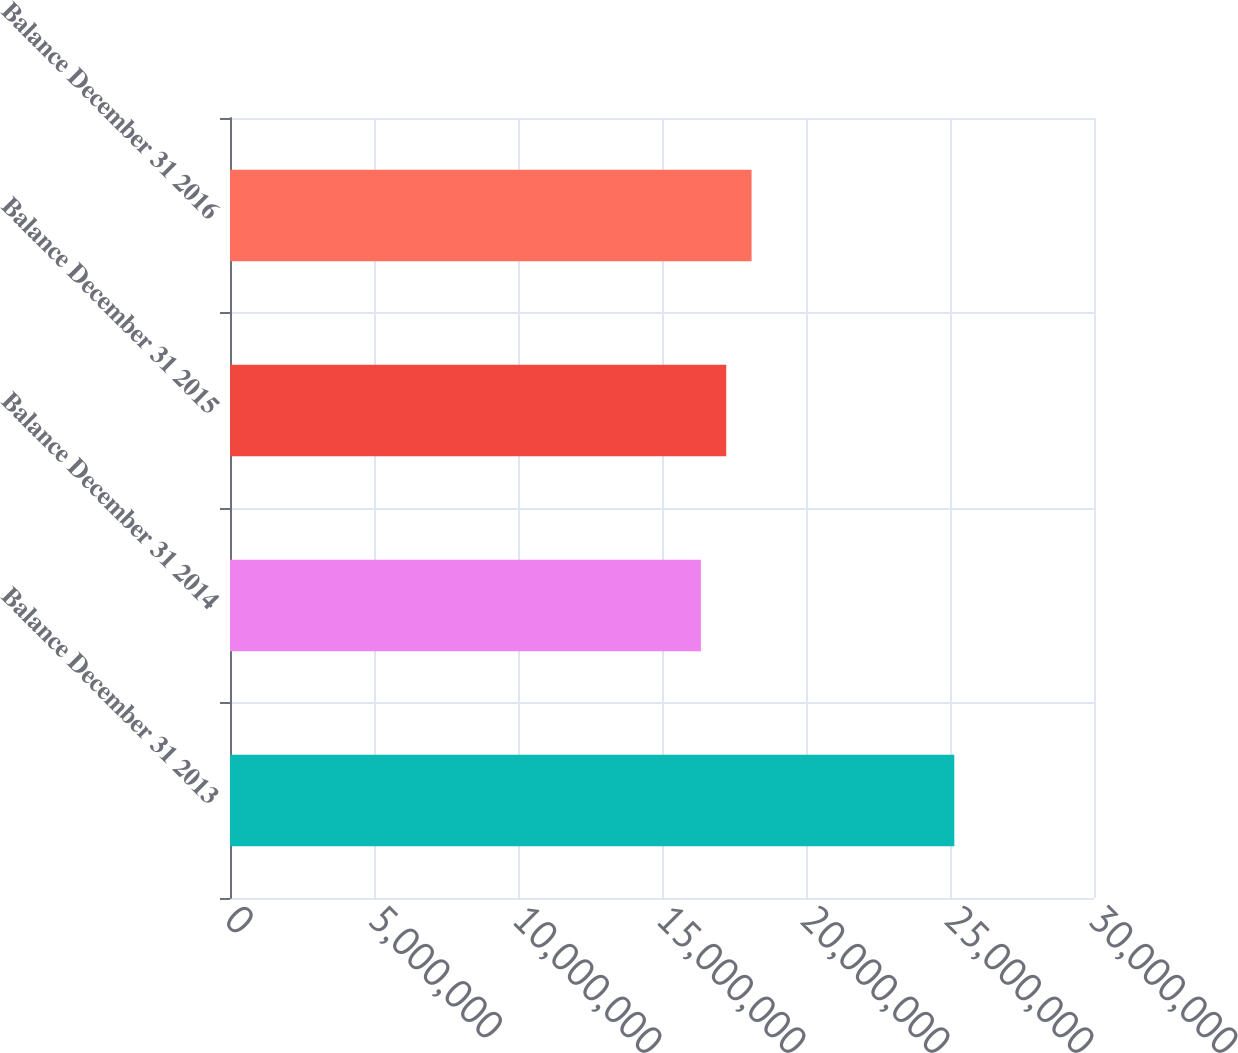Convert chart. <chart><loc_0><loc_0><loc_500><loc_500><bar_chart><fcel>Balance December 31 2013<fcel>Balance December 31 2014<fcel>Balance December 31 2015<fcel>Balance December 31 2016<nl><fcel>2.515e+07<fcel>1.635e+07<fcel>1.723e+07<fcel>1.811e+07<nl></chart> 